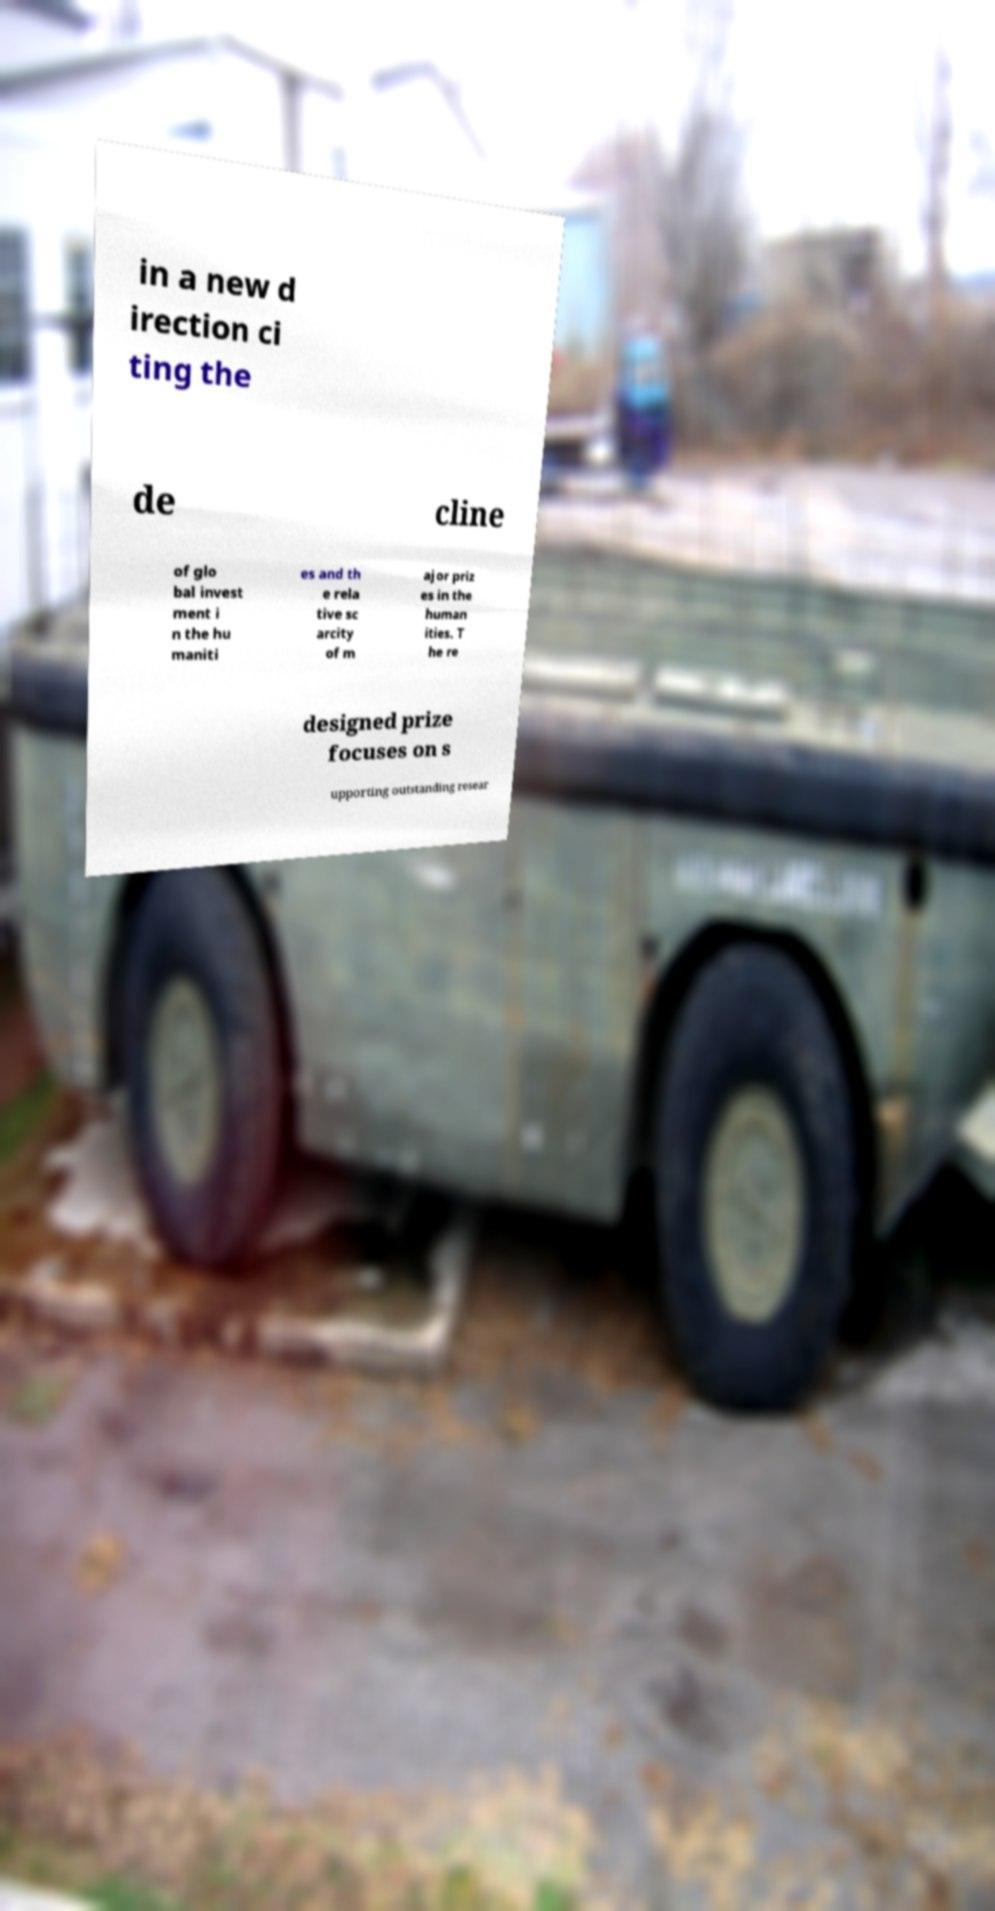Can you read and provide the text displayed in the image?This photo seems to have some interesting text. Can you extract and type it out for me? in a new d irection ci ting the de cline of glo bal invest ment i n the hu maniti es and th e rela tive sc arcity of m ajor priz es in the human ities. T he re designed prize focuses on s upporting outstanding resear 